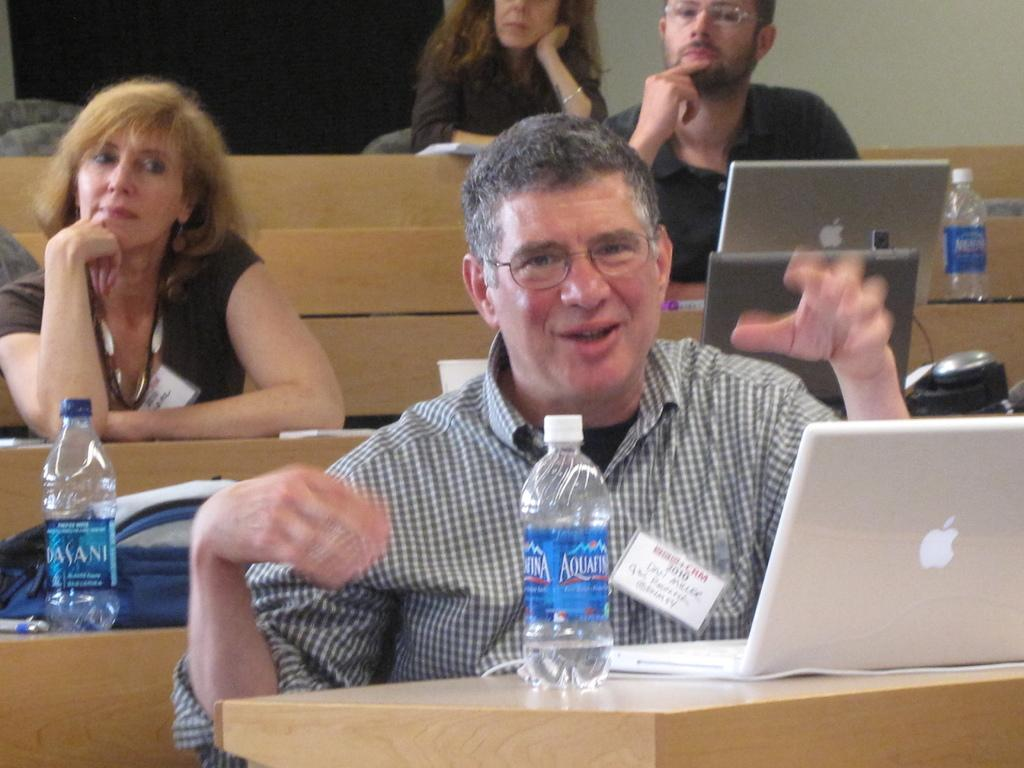How many people are in the image? There are four people in the image, two women and two men. What objects can be seen in the image that are related to technology? Laptops are visible in the image. What items might be used for hydration in the image? Water bottles are present in the image. What type of accessory is visible in the image? There is a bag in the image. Are the two women in the image sisters? There is no information provided about the relationship between the two women in the image. 